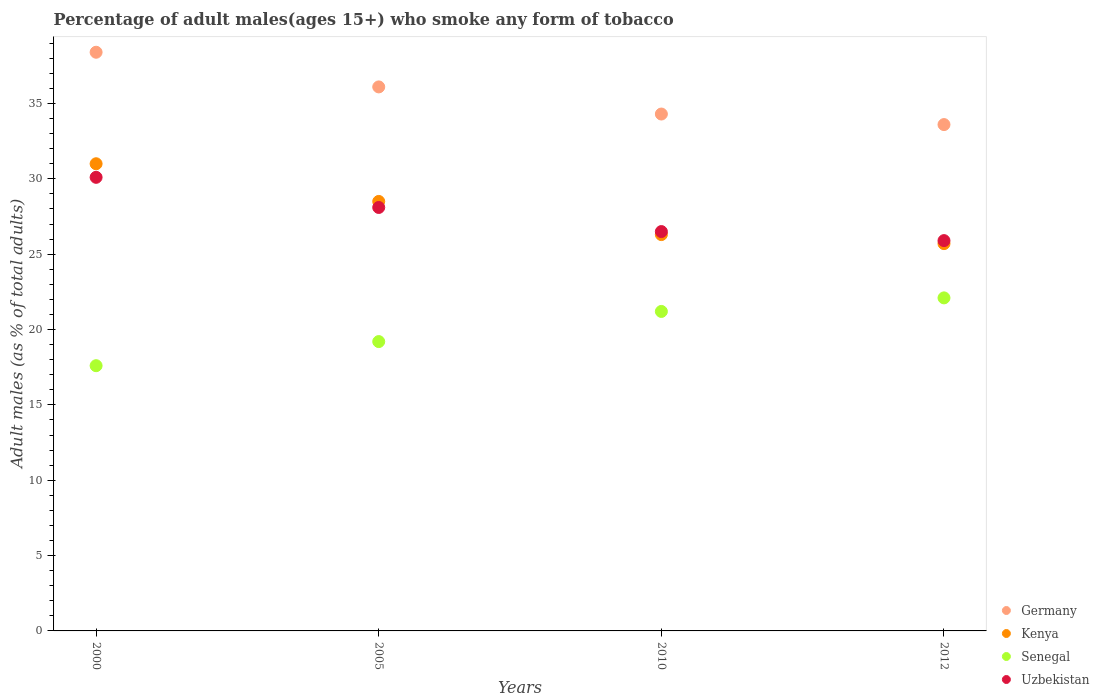How many different coloured dotlines are there?
Your answer should be compact. 4. Is the number of dotlines equal to the number of legend labels?
Ensure brevity in your answer.  Yes. What is the percentage of adult males who smoke in Senegal in 2012?
Your response must be concise. 22.1. Across all years, what is the maximum percentage of adult males who smoke in Germany?
Keep it short and to the point. 38.4. Across all years, what is the minimum percentage of adult males who smoke in Uzbekistan?
Your answer should be compact. 25.9. In which year was the percentage of adult males who smoke in Senegal maximum?
Keep it short and to the point. 2012. What is the total percentage of adult males who smoke in Germany in the graph?
Offer a terse response. 142.4. What is the difference between the percentage of adult males who smoke in Kenya in 2010 and that in 2012?
Provide a succinct answer. 0.6. What is the difference between the percentage of adult males who smoke in Kenya in 2000 and the percentage of adult males who smoke in Uzbekistan in 2005?
Provide a short and direct response. 2.9. What is the average percentage of adult males who smoke in Uzbekistan per year?
Offer a very short reply. 27.65. In the year 2010, what is the difference between the percentage of adult males who smoke in Senegal and percentage of adult males who smoke in Germany?
Offer a very short reply. -13.1. In how many years, is the percentage of adult males who smoke in Senegal greater than 10 %?
Keep it short and to the point. 4. What is the ratio of the percentage of adult males who smoke in Senegal in 2000 to that in 2005?
Keep it short and to the point. 0.92. Is the difference between the percentage of adult males who smoke in Senegal in 2010 and 2012 greater than the difference between the percentage of adult males who smoke in Germany in 2010 and 2012?
Your answer should be compact. No. What is the difference between the highest and the lowest percentage of adult males who smoke in Senegal?
Give a very brief answer. 4.5. In how many years, is the percentage of adult males who smoke in Uzbekistan greater than the average percentage of adult males who smoke in Uzbekistan taken over all years?
Offer a terse response. 2. Is the sum of the percentage of adult males who smoke in Kenya in 2005 and 2012 greater than the maximum percentage of adult males who smoke in Senegal across all years?
Your answer should be very brief. Yes. Is the percentage of adult males who smoke in Uzbekistan strictly greater than the percentage of adult males who smoke in Kenya over the years?
Your answer should be very brief. No. How many dotlines are there?
Your response must be concise. 4. How many years are there in the graph?
Ensure brevity in your answer.  4. Does the graph contain any zero values?
Provide a succinct answer. No. Does the graph contain grids?
Make the answer very short. No. Where does the legend appear in the graph?
Give a very brief answer. Bottom right. What is the title of the graph?
Keep it short and to the point. Percentage of adult males(ages 15+) who smoke any form of tobacco. What is the label or title of the X-axis?
Your response must be concise. Years. What is the label or title of the Y-axis?
Offer a very short reply. Adult males (as % of total adults). What is the Adult males (as % of total adults) of Germany in 2000?
Provide a succinct answer. 38.4. What is the Adult males (as % of total adults) in Kenya in 2000?
Keep it short and to the point. 31. What is the Adult males (as % of total adults) in Senegal in 2000?
Your answer should be very brief. 17.6. What is the Adult males (as % of total adults) of Uzbekistan in 2000?
Provide a succinct answer. 30.1. What is the Adult males (as % of total adults) of Germany in 2005?
Your answer should be compact. 36.1. What is the Adult males (as % of total adults) of Kenya in 2005?
Provide a succinct answer. 28.5. What is the Adult males (as % of total adults) in Uzbekistan in 2005?
Give a very brief answer. 28.1. What is the Adult males (as % of total adults) of Germany in 2010?
Offer a terse response. 34.3. What is the Adult males (as % of total adults) of Kenya in 2010?
Give a very brief answer. 26.3. What is the Adult males (as % of total adults) in Senegal in 2010?
Keep it short and to the point. 21.2. What is the Adult males (as % of total adults) of Uzbekistan in 2010?
Provide a short and direct response. 26.5. What is the Adult males (as % of total adults) in Germany in 2012?
Provide a succinct answer. 33.6. What is the Adult males (as % of total adults) in Kenya in 2012?
Give a very brief answer. 25.7. What is the Adult males (as % of total adults) of Senegal in 2012?
Make the answer very short. 22.1. What is the Adult males (as % of total adults) in Uzbekistan in 2012?
Make the answer very short. 25.9. Across all years, what is the maximum Adult males (as % of total adults) of Germany?
Provide a succinct answer. 38.4. Across all years, what is the maximum Adult males (as % of total adults) of Senegal?
Keep it short and to the point. 22.1. Across all years, what is the maximum Adult males (as % of total adults) of Uzbekistan?
Your response must be concise. 30.1. Across all years, what is the minimum Adult males (as % of total adults) of Germany?
Keep it short and to the point. 33.6. Across all years, what is the minimum Adult males (as % of total adults) in Kenya?
Ensure brevity in your answer.  25.7. Across all years, what is the minimum Adult males (as % of total adults) of Uzbekistan?
Your answer should be compact. 25.9. What is the total Adult males (as % of total adults) of Germany in the graph?
Ensure brevity in your answer.  142.4. What is the total Adult males (as % of total adults) in Kenya in the graph?
Your answer should be compact. 111.5. What is the total Adult males (as % of total adults) in Senegal in the graph?
Provide a short and direct response. 80.1. What is the total Adult males (as % of total adults) in Uzbekistan in the graph?
Keep it short and to the point. 110.6. What is the difference between the Adult males (as % of total adults) in Germany in 2000 and that in 2005?
Offer a terse response. 2.3. What is the difference between the Adult males (as % of total adults) in Germany in 2000 and that in 2010?
Your response must be concise. 4.1. What is the difference between the Adult males (as % of total adults) in Kenya in 2000 and that in 2010?
Your answer should be compact. 4.7. What is the difference between the Adult males (as % of total adults) of Germany in 2000 and that in 2012?
Ensure brevity in your answer.  4.8. What is the difference between the Adult males (as % of total adults) of Senegal in 2000 and that in 2012?
Offer a terse response. -4.5. What is the difference between the Adult males (as % of total adults) of Uzbekistan in 2000 and that in 2012?
Provide a short and direct response. 4.2. What is the difference between the Adult males (as % of total adults) of Germany in 2005 and that in 2010?
Give a very brief answer. 1.8. What is the difference between the Adult males (as % of total adults) of Uzbekistan in 2005 and that in 2010?
Make the answer very short. 1.6. What is the difference between the Adult males (as % of total adults) of Uzbekistan in 2005 and that in 2012?
Your answer should be very brief. 2.2. What is the difference between the Adult males (as % of total adults) in Germany in 2010 and that in 2012?
Your answer should be very brief. 0.7. What is the difference between the Adult males (as % of total adults) of Kenya in 2010 and that in 2012?
Make the answer very short. 0.6. What is the difference between the Adult males (as % of total adults) in Germany in 2000 and the Adult males (as % of total adults) in Senegal in 2005?
Offer a terse response. 19.2. What is the difference between the Adult males (as % of total adults) of Germany in 2000 and the Adult males (as % of total adults) of Uzbekistan in 2005?
Your answer should be compact. 10.3. What is the difference between the Adult males (as % of total adults) of Senegal in 2000 and the Adult males (as % of total adults) of Uzbekistan in 2005?
Ensure brevity in your answer.  -10.5. What is the difference between the Adult males (as % of total adults) of Germany in 2000 and the Adult males (as % of total adults) of Kenya in 2010?
Ensure brevity in your answer.  12.1. What is the difference between the Adult males (as % of total adults) of Germany in 2000 and the Adult males (as % of total adults) of Uzbekistan in 2010?
Offer a terse response. 11.9. What is the difference between the Adult males (as % of total adults) of Kenya in 2000 and the Adult males (as % of total adults) of Senegal in 2010?
Give a very brief answer. 9.8. What is the difference between the Adult males (as % of total adults) of Germany in 2000 and the Adult males (as % of total adults) of Kenya in 2012?
Offer a terse response. 12.7. What is the difference between the Adult males (as % of total adults) in Senegal in 2000 and the Adult males (as % of total adults) in Uzbekistan in 2012?
Provide a succinct answer. -8.3. What is the difference between the Adult males (as % of total adults) of Kenya in 2005 and the Adult males (as % of total adults) of Uzbekistan in 2010?
Offer a terse response. 2. What is the difference between the Adult males (as % of total adults) in Senegal in 2005 and the Adult males (as % of total adults) in Uzbekistan in 2010?
Your response must be concise. -7.3. What is the difference between the Adult males (as % of total adults) of Germany in 2005 and the Adult males (as % of total adults) of Kenya in 2012?
Offer a terse response. 10.4. What is the difference between the Adult males (as % of total adults) of Germany in 2005 and the Adult males (as % of total adults) of Senegal in 2012?
Ensure brevity in your answer.  14. What is the difference between the Adult males (as % of total adults) of Germany in 2005 and the Adult males (as % of total adults) of Uzbekistan in 2012?
Ensure brevity in your answer.  10.2. What is the difference between the Adult males (as % of total adults) of Kenya in 2005 and the Adult males (as % of total adults) of Uzbekistan in 2012?
Your answer should be compact. 2.6. What is the difference between the Adult males (as % of total adults) in Senegal in 2005 and the Adult males (as % of total adults) in Uzbekistan in 2012?
Your response must be concise. -6.7. What is the difference between the Adult males (as % of total adults) in Germany in 2010 and the Adult males (as % of total adults) in Senegal in 2012?
Offer a terse response. 12.2. What is the difference between the Adult males (as % of total adults) in Kenya in 2010 and the Adult males (as % of total adults) in Senegal in 2012?
Provide a short and direct response. 4.2. What is the difference between the Adult males (as % of total adults) in Senegal in 2010 and the Adult males (as % of total adults) in Uzbekistan in 2012?
Provide a short and direct response. -4.7. What is the average Adult males (as % of total adults) of Germany per year?
Make the answer very short. 35.6. What is the average Adult males (as % of total adults) in Kenya per year?
Make the answer very short. 27.88. What is the average Adult males (as % of total adults) of Senegal per year?
Offer a very short reply. 20.02. What is the average Adult males (as % of total adults) in Uzbekistan per year?
Offer a very short reply. 27.65. In the year 2000, what is the difference between the Adult males (as % of total adults) of Germany and Adult males (as % of total adults) of Kenya?
Provide a short and direct response. 7.4. In the year 2000, what is the difference between the Adult males (as % of total adults) of Germany and Adult males (as % of total adults) of Senegal?
Your answer should be compact. 20.8. In the year 2000, what is the difference between the Adult males (as % of total adults) of Germany and Adult males (as % of total adults) of Uzbekistan?
Provide a succinct answer. 8.3. In the year 2000, what is the difference between the Adult males (as % of total adults) of Senegal and Adult males (as % of total adults) of Uzbekistan?
Your response must be concise. -12.5. In the year 2005, what is the difference between the Adult males (as % of total adults) of Germany and Adult males (as % of total adults) of Senegal?
Give a very brief answer. 16.9. In the year 2005, what is the difference between the Adult males (as % of total adults) of Kenya and Adult males (as % of total adults) of Senegal?
Make the answer very short. 9.3. In the year 2005, what is the difference between the Adult males (as % of total adults) of Kenya and Adult males (as % of total adults) of Uzbekistan?
Ensure brevity in your answer.  0.4. In the year 2010, what is the difference between the Adult males (as % of total adults) in Germany and Adult males (as % of total adults) in Senegal?
Provide a short and direct response. 13.1. In the year 2012, what is the difference between the Adult males (as % of total adults) of Germany and Adult males (as % of total adults) of Kenya?
Offer a terse response. 7.9. In the year 2012, what is the difference between the Adult males (as % of total adults) of Germany and Adult males (as % of total adults) of Uzbekistan?
Give a very brief answer. 7.7. What is the ratio of the Adult males (as % of total adults) of Germany in 2000 to that in 2005?
Your answer should be very brief. 1.06. What is the ratio of the Adult males (as % of total adults) of Kenya in 2000 to that in 2005?
Your response must be concise. 1.09. What is the ratio of the Adult males (as % of total adults) in Uzbekistan in 2000 to that in 2005?
Your answer should be compact. 1.07. What is the ratio of the Adult males (as % of total adults) in Germany in 2000 to that in 2010?
Provide a succinct answer. 1.12. What is the ratio of the Adult males (as % of total adults) of Kenya in 2000 to that in 2010?
Make the answer very short. 1.18. What is the ratio of the Adult males (as % of total adults) of Senegal in 2000 to that in 2010?
Keep it short and to the point. 0.83. What is the ratio of the Adult males (as % of total adults) of Uzbekistan in 2000 to that in 2010?
Offer a very short reply. 1.14. What is the ratio of the Adult males (as % of total adults) of Kenya in 2000 to that in 2012?
Your answer should be very brief. 1.21. What is the ratio of the Adult males (as % of total adults) in Senegal in 2000 to that in 2012?
Your response must be concise. 0.8. What is the ratio of the Adult males (as % of total adults) in Uzbekistan in 2000 to that in 2012?
Offer a terse response. 1.16. What is the ratio of the Adult males (as % of total adults) of Germany in 2005 to that in 2010?
Offer a very short reply. 1.05. What is the ratio of the Adult males (as % of total adults) in Kenya in 2005 to that in 2010?
Your response must be concise. 1.08. What is the ratio of the Adult males (as % of total adults) in Senegal in 2005 to that in 2010?
Give a very brief answer. 0.91. What is the ratio of the Adult males (as % of total adults) of Uzbekistan in 2005 to that in 2010?
Your response must be concise. 1.06. What is the ratio of the Adult males (as % of total adults) of Germany in 2005 to that in 2012?
Your response must be concise. 1.07. What is the ratio of the Adult males (as % of total adults) of Kenya in 2005 to that in 2012?
Your answer should be compact. 1.11. What is the ratio of the Adult males (as % of total adults) of Senegal in 2005 to that in 2012?
Provide a succinct answer. 0.87. What is the ratio of the Adult males (as % of total adults) of Uzbekistan in 2005 to that in 2012?
Make the answer very short. 1.08. What is the ratio of the Adult males (as % of total adults) in Germany in 2010 to that in 2012?
Your answer should be compact. 1.02. What is the ratio of the Adult males (as % of total adults) in Kenya in 2010 to that in 2012?
Give a very brief answer. 1.02. What is the ratio of the Adult males (as % of total adults) in Senegal in 2010 to that in 2012?
Offer a terse response. 0.96. What is the ratio of the Adult males (as % of total adults) of Uzbekistan in 2010 to that in 2012?
Make the answer very short. 1.02. What is the difference between the highest and the second highest Adult males (as % of total adults) of Germany?
Offer a terse response. 2.3. What is the difference between the highest and the second highest Adult males (as % of total adults) of Kenya?
Your answer should be compact. 2.5. What is the difference between the highest and the second highest Adult males (as % of total adults) in Senegal?
Provide a succinct answer. 0.9. What is the difference between the highest and the second highest Adult males (as % of total adults) of Uzbekistan?
Make the answer very short. 2. What is the difference between the highest and the lowest Adult males (as % of total adults) of Germany?
Give a very brief answer. 4.8. What is the difference between the highest and the lowest Adult males (as % of total adults) of Senegal?
Keep it short and to the point. 4.5. What is the difference between the highest and the lowest Adult males (as % of total adults) in Uzbekistan?
Give a very brief answer. 4.2. 